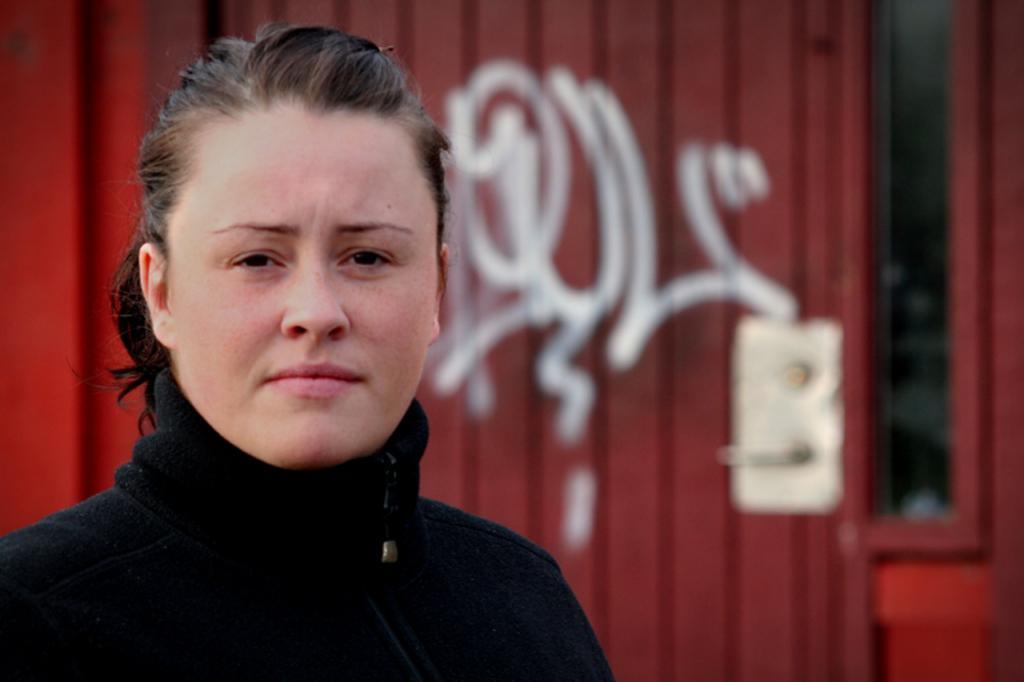Can you describe this image briefly? In this image we can see a person wearing black color dress, in the background we can see a door. 